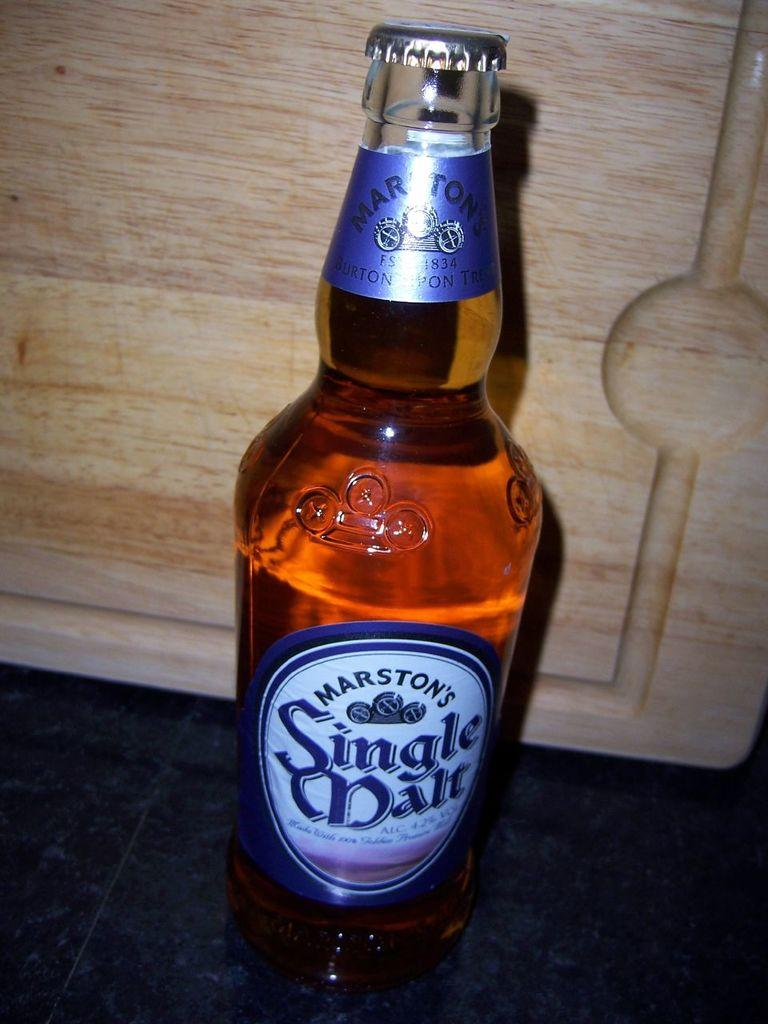<image>
Provide a brief description of the given image. A closed bottle of alcohol by the brand Marston's. 